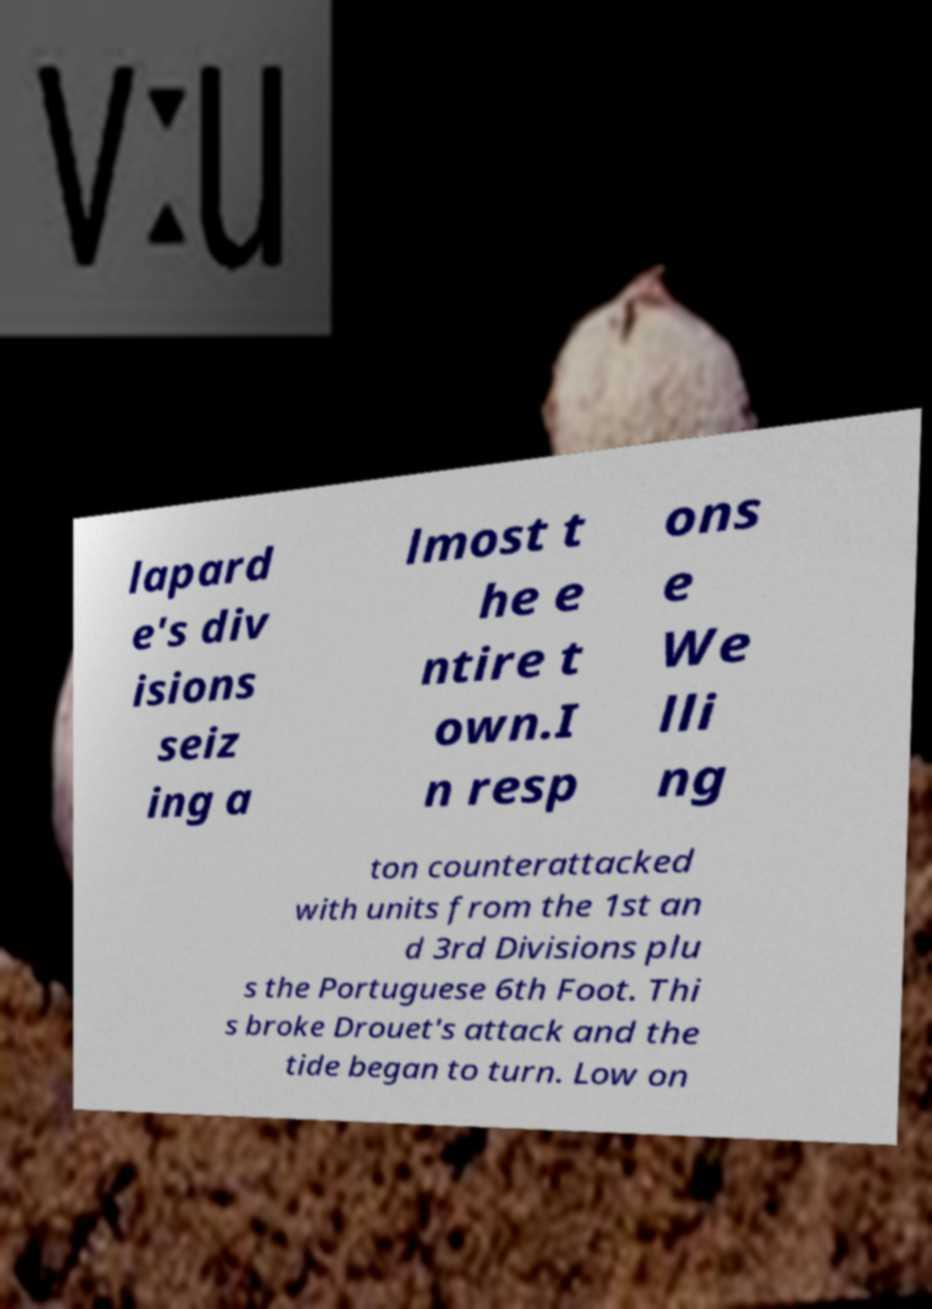For documentation purposes, I need the text within this image transcribed. Could you provide that? lapard e's div isions seiz ing a lmost t he e ntire t own.I n resp ons e We lli ng ton counterattacked with units from the 1st an d 3rd Divisions plu s the Portuguese 6th Foot. Thi s broke Drouet's attack and the tide began to turn. Low on 